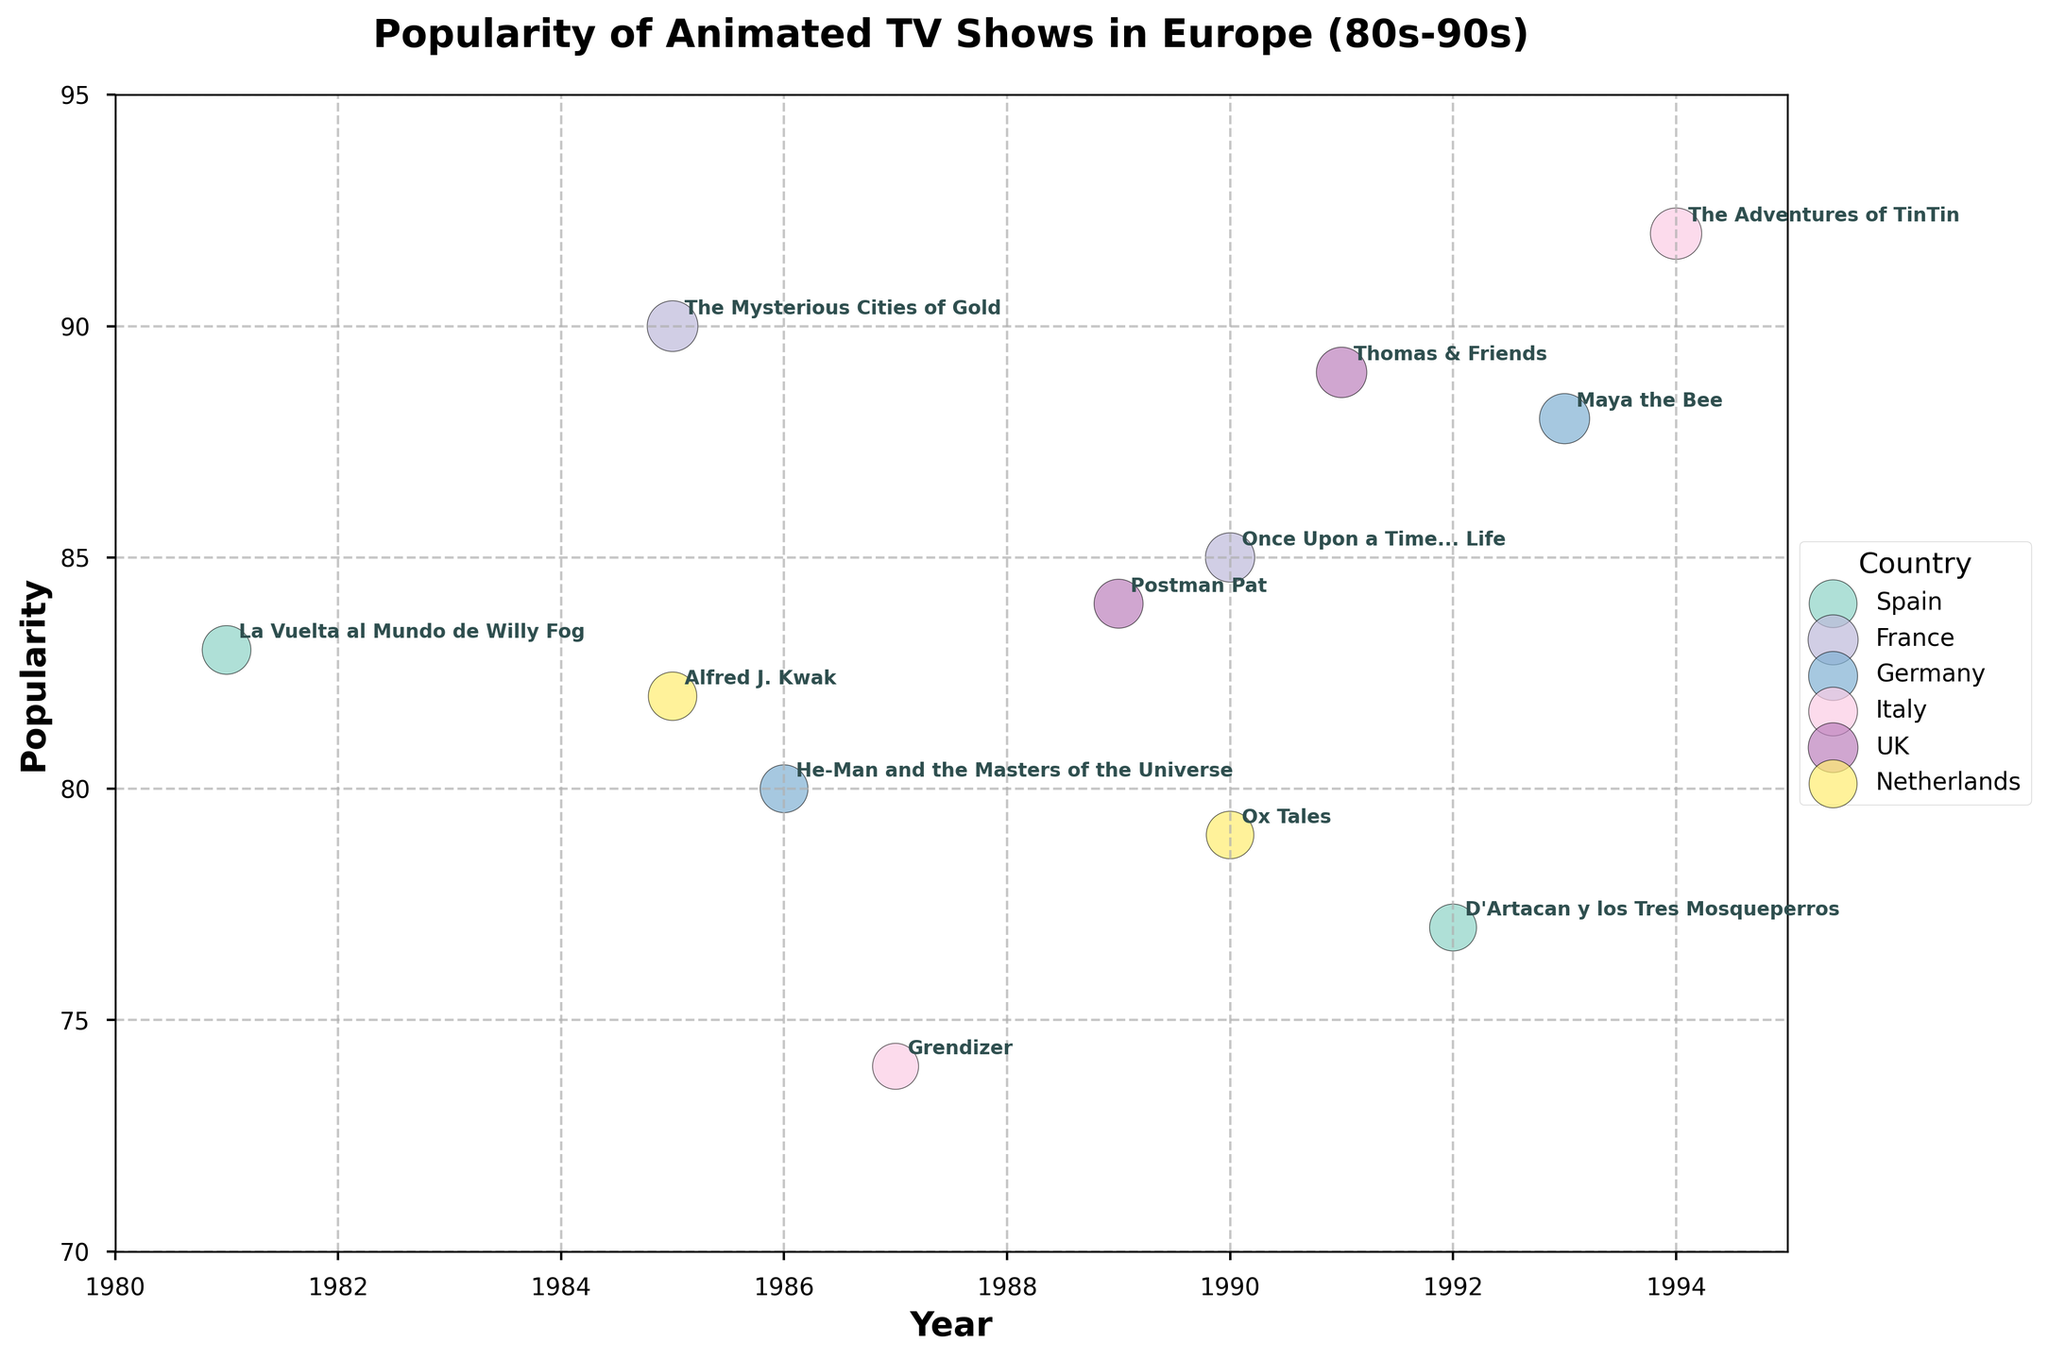What's the title of the figure? The title is usually displayed at the top of the figure in a larger and bolder font compared to other text labels. Here, it reads "Popularity of Animated TV Shows in Europe (80s-90s)".
Answer: Popularity of Animated TV Shows in Europe (80s-90s) What are the labels for the X and Y axes? The labels for the axes are typically shown along the sides of the plot area. Here, the X-axis is labeled 'Year' and the Y-axis is labeled 'Popularity'.
Answer: Year, Popularity Which country has the show with the highest popularity? To find the highest popularity, check the Y-axis values of the bubbles. The show with the highest Y-coordinate is 'The Adventures of TinTin' from Italy with a popularity of 92, making Italy the country with the highest popularity.
Answer: Italy Between 1985 and 1990, which show from France had higher popularity? To determine this, compare the Y-coordinates of the French shows within the specified years. 'The Mysterious Cities of Gold' (1985) has a popularity of 90, and 'Once Upon a Time... Life' (1990) has a popularity of 85. 'The Mysterious Cities of Gold' has higher popularity.
Answer: The Mysterious Cities of Gold What's the average popularity of the UK shows? Locate the bubbles representing UK shows and note their popularity values, which are 84 for 'Postman Pat' and 89 for 'Thomas & Friends'. Compute average as (84 + 89) / 2.
Answer: 86.5 Which show had the least popularity in the Netherlands? Find the Netherlands' shows by looking for these country's bubbles and compare their popularity. 'Ox Tales' has a popularity of 79, while 'Alfred J. Kwak' has 82. Hence, 'Ox Tales' has the least popularity.
Answer: Ox Tales What is the popularity difference between 'D'Artacan y los Tres Mosqueperros' and 'La Vuelta al Mundo de Willy Fog'? These shows are from Spain. 'La Vuelta al Mundo de Willy Fog' has a popularity of 83, and 'D'Artacan y los Tres Mosqueperros' has 77. The difference is calculated as 83 - 77.
Answer: 6 How many shows are listed for the year 1990? Identify the bubbles aligned vertically above the 1990 mark on the X-axis. There are three shows: 'Once Upon a Time... Life', 'Ox Tales', and 'Thomas & Friends'.
Answer: 3 Which Italian show had a lower popularity, 'Grendizer' or 'The Adventures of TinTin'? Compare the Y-coordinates of the two Italian shows. 'Grendizer' has a popularity of 74, and 'The Adventures of TinTin' has 92. 'Grendizer' has lower popularity.
Answer: Grendizer How many countries have shows listed on this plot? Determine the number of unique categories in the legend, which corresponds to the countries. The countries listed are Spain, France, Germany, Italy, UK, and Netherlands.
Answer: 6 